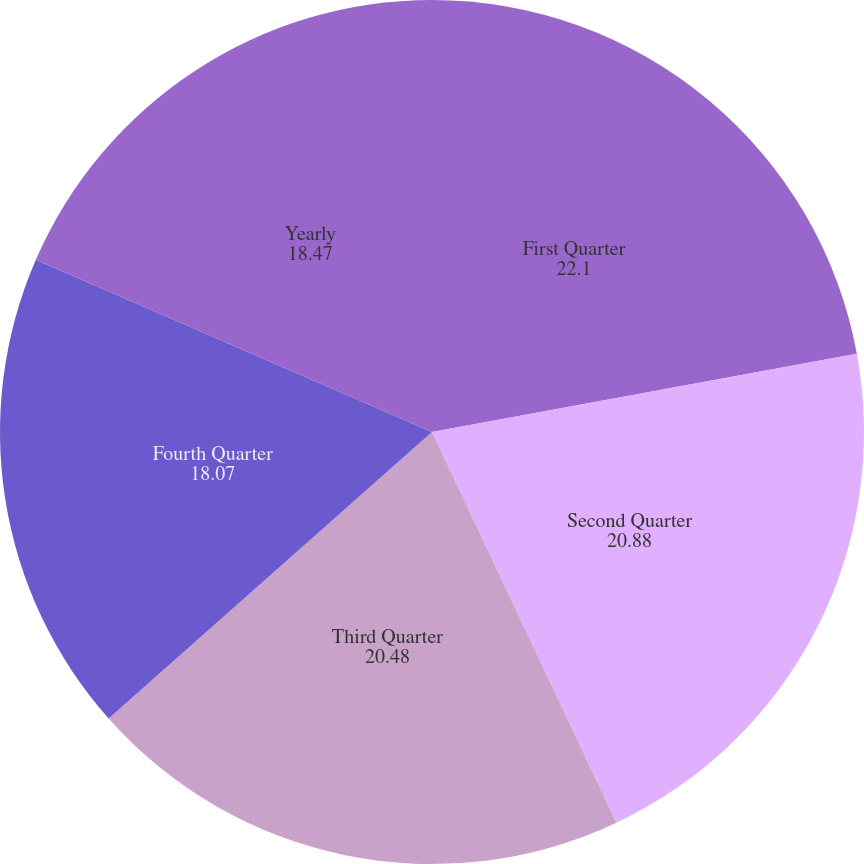Convert chart. <chart><loc_0><loc_0><loc_500><loc_500><pie_chart><fcel>First Quarter<fcel>Second Quarter<fcel>Third Quarter<fcel>Fourth Quarter<fcel>Yearly<nl><fcel>22.1%<fcel>20.88%<fcel>20.48%<fcel>18.07%<fcel>18.47%<nl></chart> 